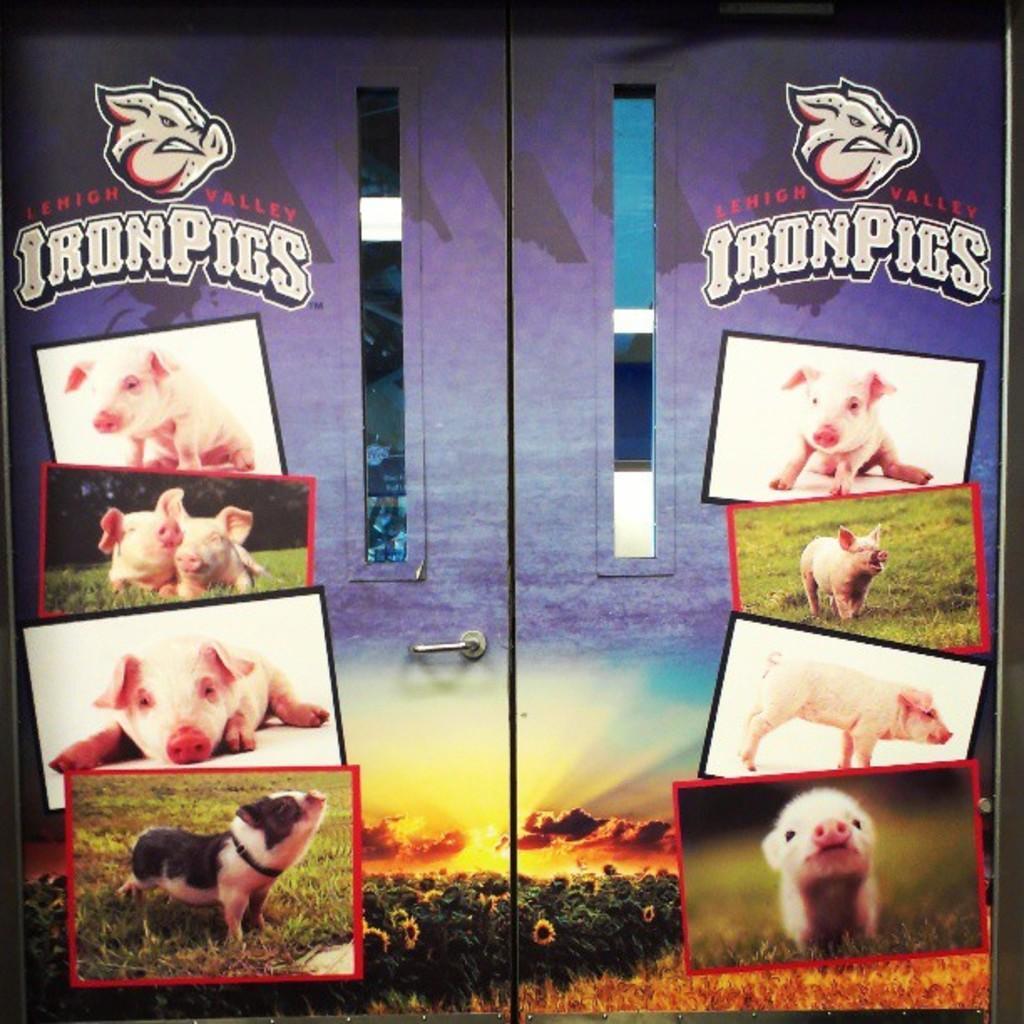How would you summarize this image in a sentence or two? In this image we can see a board of a cupboard with a handle. On the cupboard we can see some pictures of a pig. 